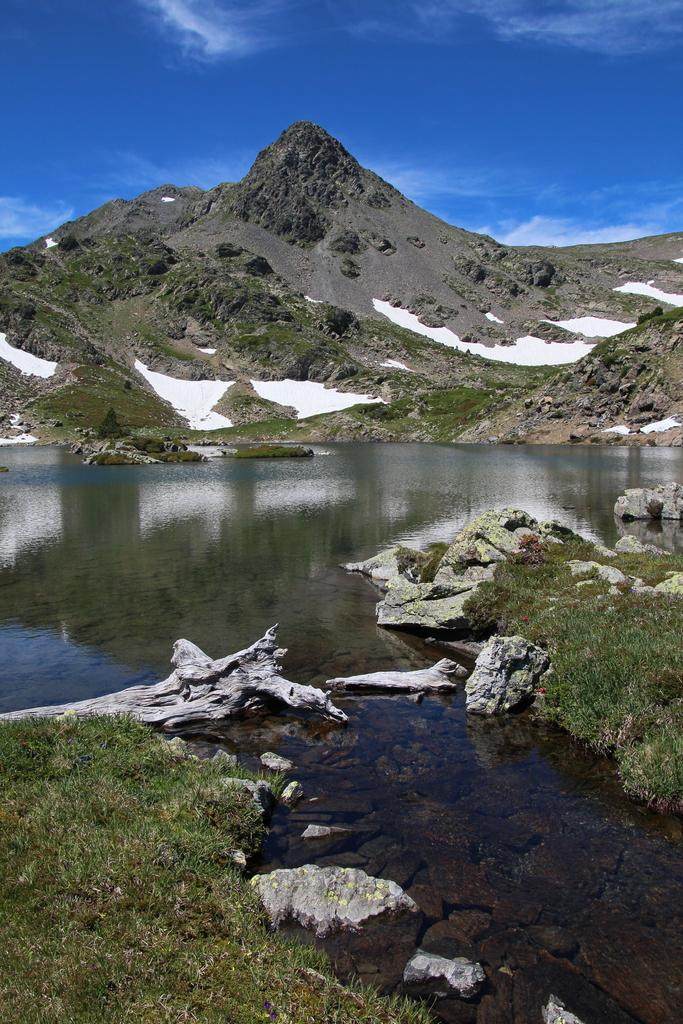What is the main feature in the center of the image? There is a mountain in the center of the image. What can be seen at the bottom of the image? There is water and grass at the bottom of the image. What is visible at the top of the image? The sky is visible at the top of the image. How many potatoes can be seen growing on the mountain in the image? There are no potatoes visible in the image; the mountain is not a potato-growing area. 